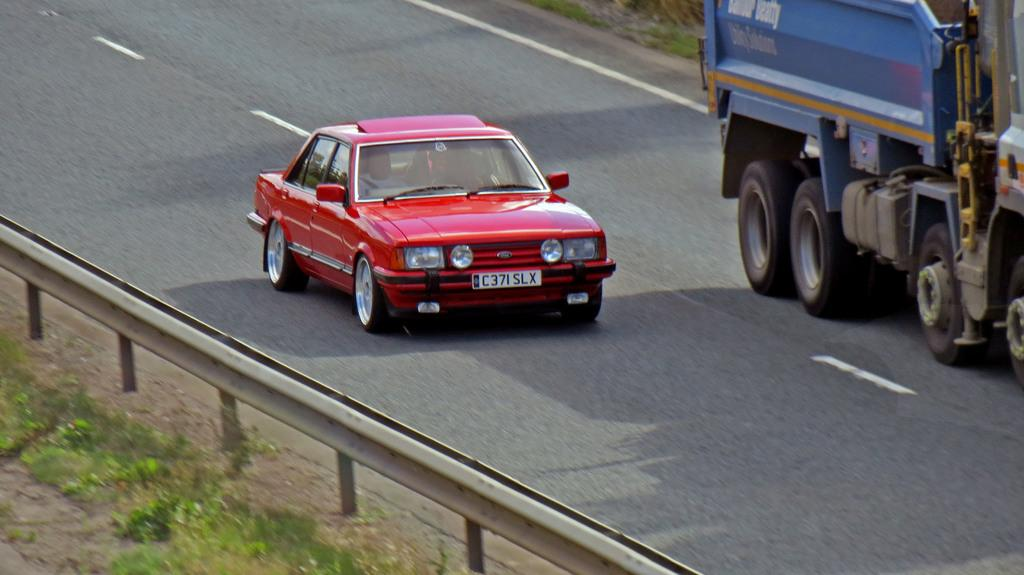What is the main subject of the image? The main subject of the image is a car. What else can be seen on the road in the image? There is another vehicle moving on the road. What is located on the left side of the image? There is a fencing on the left side of the image. What type of vegetation is visible behind the fencing? There is grass behind the fencing. What type of acoustics can be heard from the car in the image? There is no information about the acoustics of the car in the image, as it only shows the car and other elements visually. 